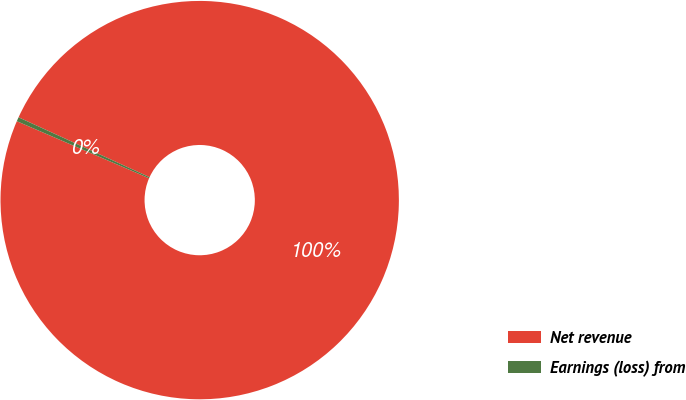Convert chart to OTSL. <chart><loc_0><loc_0><loc_500><loc_500><pie_chart><fcel>Net revenue<fcel>Earnings (loss) from<nl><fcel>99.66%<fcel>0.34%<nl></chart> 